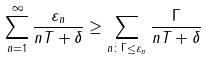<formula> <loc_0><loc_0><loc_500><loc_500>\sum _ { n = 1 } ^ { \infty } \frac { \varepsilon _ { n } } { n T + \delta } \geq \sum _ { n \colon \Gamma \leq \varepsilon _ { n } } \frac { \Gamma } { n T + \delta }</formula> 